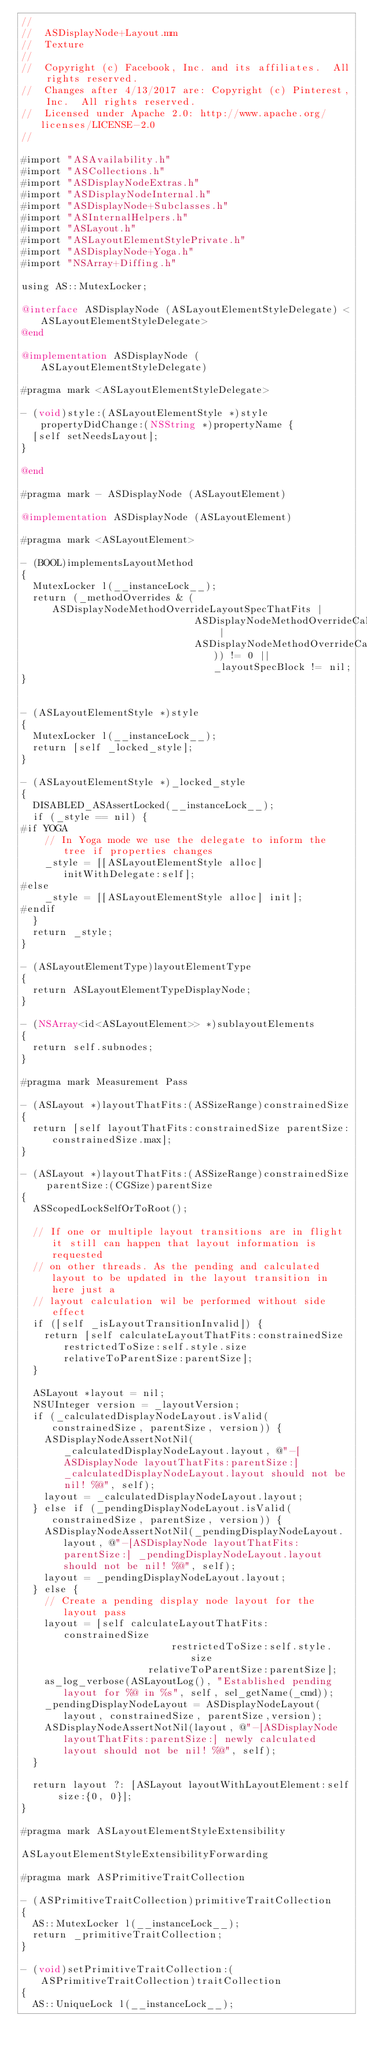<code> <loc_0><loc_0><loc_500><loc_500><_ObjectiveC_>//
//  ASDisplayNode+Layout.mm
//  Texture
//
//  Copyright (c) Facebook, Inc. and its affiliates.  All rights reserved.
//  Changes after 4/13/2017 are: Copyright (c) Pinterest, Inc.  All rights reserved.
//  Licensed under Apache 2.0: http://www.apache.org/licenses/LICENSE-2.0
//

#import "ASAvailability.h"
#import "ASCollections.h"
#import "ASDisplayNodeExtras.h"
#import "ASDisplayNodeInternal.h"
#import "ASDisplayNode+Subclasses.h"
#import "ASInternalHelpers.h"
#import "ASLayout.h"
#import "ASLayoutElementStylePrivate.h"
#import "ASDisplayNode+Yoga.h"
#import "NSArray+Diffing.h"

using AS::MutexLocker;

@interface ASDisplayNode (ASLayoutElementStyleDelegate) <ASLayoutElementStyleDelegate>
@end

@implementation ASDisplayNode (ASLayoutElementStyleDelegate)

#pragma mark <ASLayoutElementStyleDelegate>

- (void)style:(ASLayoutElementStyle *)style propertyDidChange:(NSString *)propertyName {
  [self setNeedsLayout];
}

@end

#pragma mark - ASDisplayNode (ASLayoutElement)

@implementation ASDisplayNode (ASLayoutElement)

#pragma mark <ASLayoutElement>

- (BOOL)implementsLayoutMethod
{
  MutexLocker l(__instanceLock__);
  return (_methodOverrides & (ASDisplayNodeMethodOverrideLayoutSpecThatFits |
                              ASDisplayNodeMethodOverrideCalcLayoutThatFits |
                              ASDisplayNodeMethodOverrideCalcSizeThatFits)) != 0 || _layoutSpecBlock != nil;
}


- (ASLayoutElementStyle *)style
{
  MutexLocker l(__instanceLock__);
  return [self _locked_style];
}

- (ASLayoutElementStyle *)_locked_style
{
  DISABLED_ASAssertLocked(__instanceLock__);
  if (_style == nil) {
#if YOGA
    // In Yoga mode we use the delegate to inform the tree if properties changes
    _style = [[ASLayoutElementStyle alloc] initWithDelegate:self];
#else
    _style = [[ASLayoutElementStyle alloc] init];
#endif
  }
  return _style;
}

- (ASLayoutElementType)layoutElementType
{
  return ASLayoutElementTypeDisplayNode;
}

- (NSArray<id<ASLayoutElement>> *)sublayoutElements
{
  return self.subnodes;
}

#pragma mark Measurement Pass

- (ASLayout *)layoutThatFits:(ASSizeRange)constrainedSize
{
  return [self layoutThatFits:constrainedSize parentSize:constrainedSize.max];
}

- (ASLayout *)layoutThatFits:(ASSizeRange)constrainedSize parentSize:(CGSize)parentSize
{
  ASScopedLockSelfOrToRoot();

  // If one or multiple layout transitions are in flight it still can happen that layout information is requested
  // on other threads. As the pending and calculated layout to be updated in the layout transition in here just a
  // layout calculation wil be performed without side effect
  if ([self _isLayoutTransitionInvalid]) {
    return [self calculateLayoutThatFits:constrainedSize restrictedToSize:self.style.size relativeToParentSize:parentSize];
  }

  ASLayout *layout = nil;
  NSUInteger version = _layoutVersion;
  if (_calculatedDisplayNodeLayout.isValid(constrainedSize, parentSize, version)) {
    ASDisplayNodeAssertNotNil(_calculatedDisplayNodeLayout.layout, @"-[ASDisplayNode layoutThatFits:parentSize:] _calculatedDisplayNodeLayout.layout should not be nil! %@", self);
    layout = _calculatedDisplayNodeLayout.layout;
  } else if (_pendingDisplayNodeLayout.isValid(constrainedSize, parentSize, version)) {
    ASDisplayNodeAssertNotNil(_pendingDisplayNodeLayout.layout, @"-[ASDisplayNode layoutThatFits:parentSize:] _pendingDisplayNodeLayout.layout should not be nil! %@", self);
    layout = _pendingDisplayNodeLayout.layout;
  } else {
    // Create a pending display node layout for the layout pass
    layout = [self calculateLayoutThatFits:constrainedSize
                          restrictedToSize:self.style.size
                      relativeToParentSize:parentSize];
    as_log_verbose(ASLayoutLog(), "Established pending layout for %@ in %s", self, sel_getName(_cmd));
    _pendingDisplayNodeLayout = ASDisplayNodeLayout(layout, constrainedSize, parentSize,version);
    ASDisplayNodeAssertNotNil(layout, @"-[ASDisplayNode layoutThatFits:parentSize:] newly calculated layout should not be nil! %@", self);
  }
  
  return layout ?: [ASLayout layoutWithLayoutElement:self size:{0, 0}];
}

#pragma mark ASLayoutElementStyleExtensibility

ASLayoutElementStyleExtensibilityForwarding

#pragma mark ASPrimitiveTraitCollection

- (ASPrimitiveTraitCollection)primitiveTraitCollection
{
  AS::MutexLocker l(__instanceLock__);
  return _primitiveTraitCollection;
}

- (void)setPrimitiveTraitCollection:(ASPrimitiveTraitCollection)traitCollection
{
  AS::UniqueLock l(__instanceLock__);</code> 